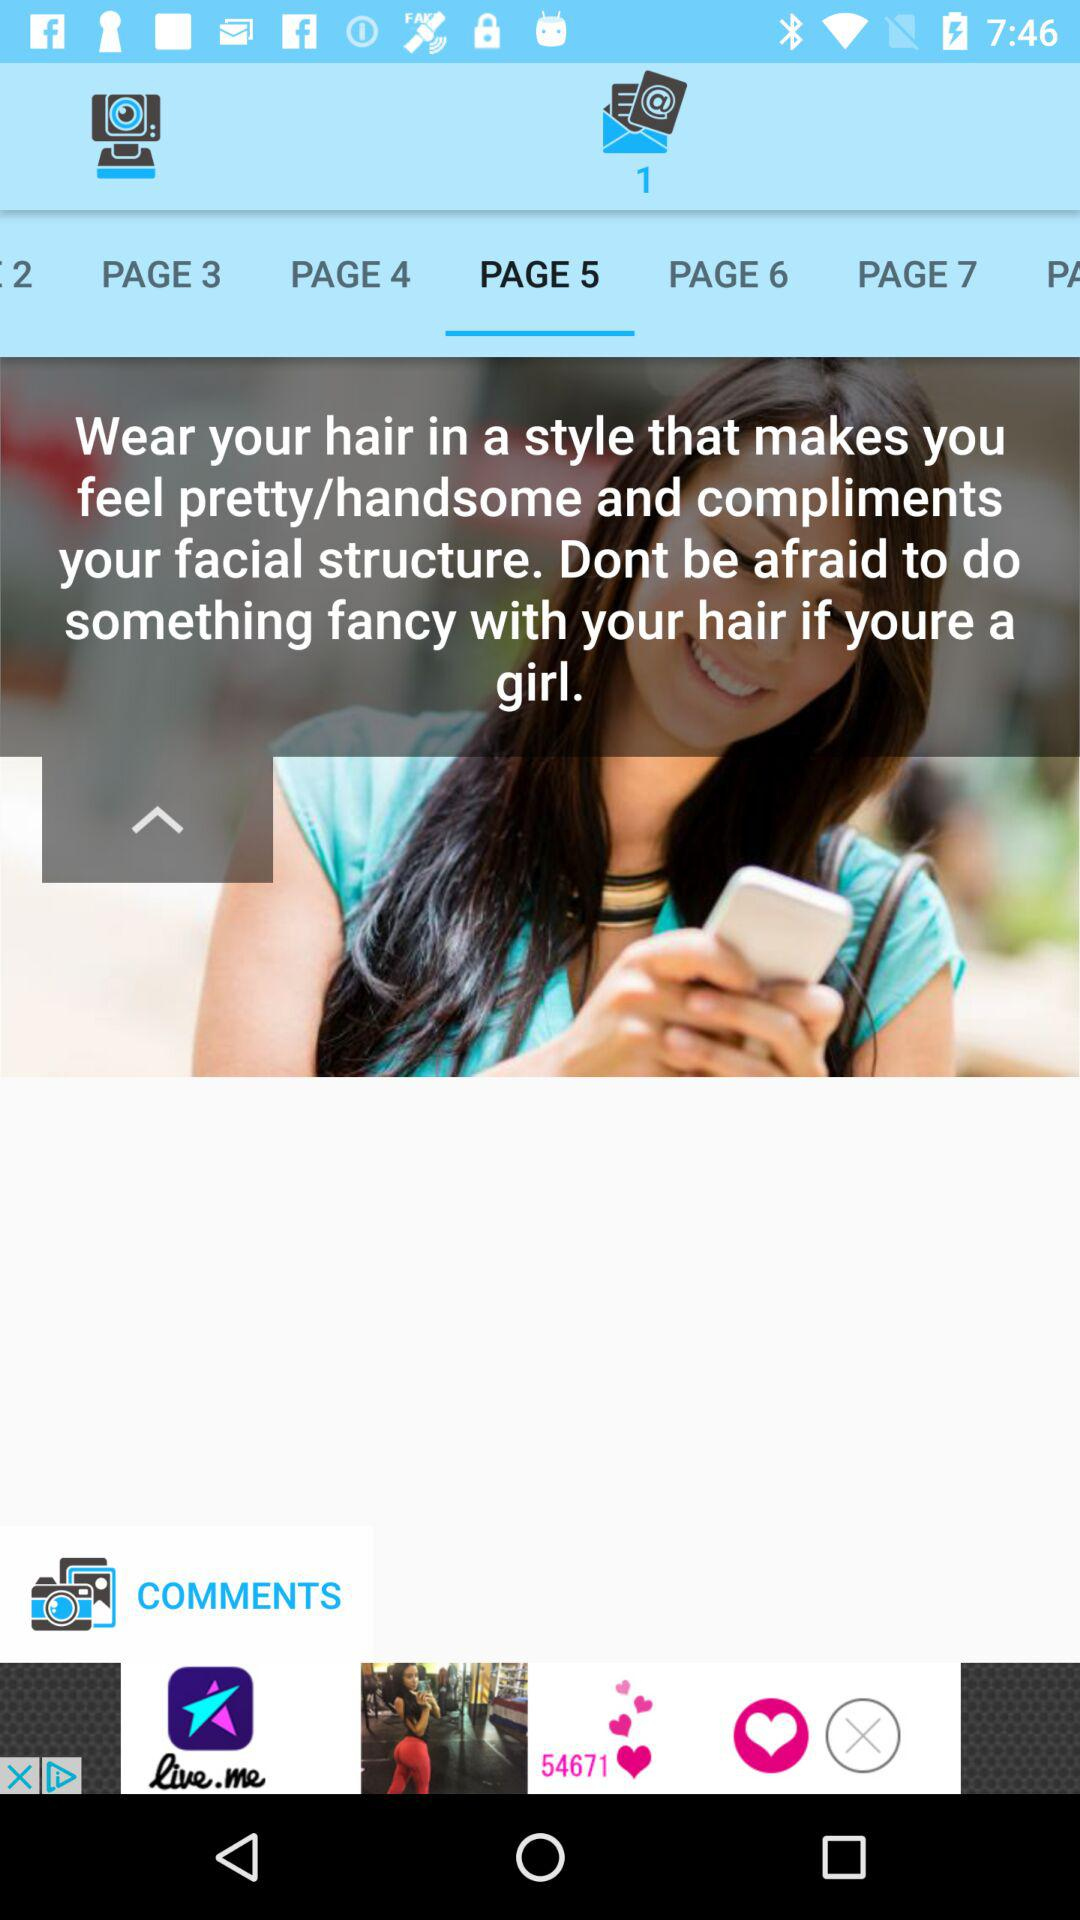How many followers are there?
When the provided information is insufficient, respond with <no answer>. <no answer> 